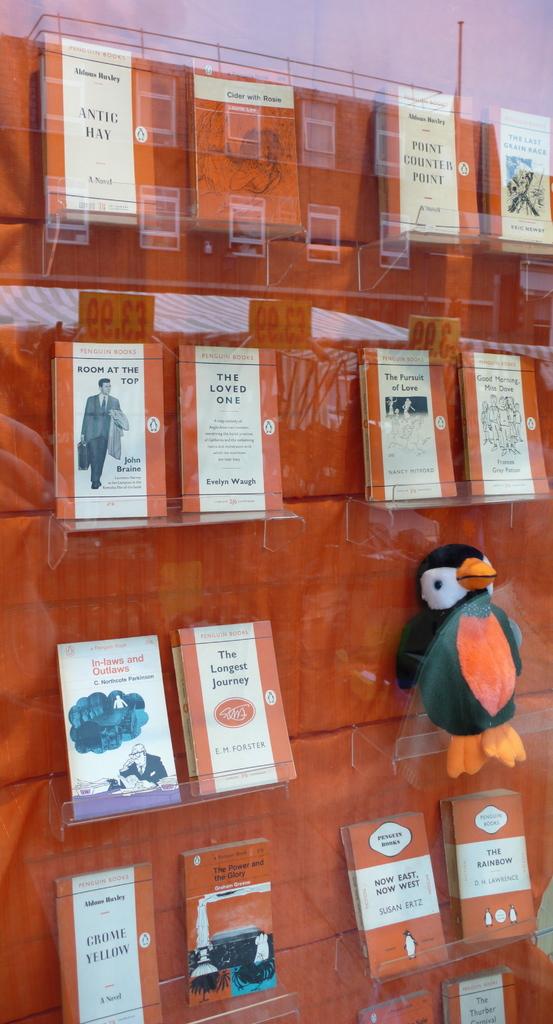Are these boks?
Ensure brevity in your answer.  Yes. 